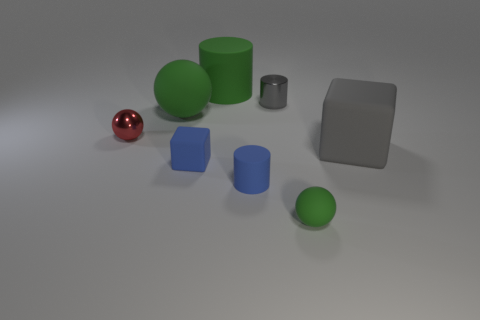There is a block behind the tiny blue rubber object that is on the left side of the small blue rubber thing that is on the right side of the green cylinder; what color is it?
Ensure brevity in your answer.  Gray. Is the shape of the large gray rubber object the same as the tiny green object?
Your response must be concise. No. Is the number of small gray shiny things in front of the small gray cylinder the same as the number of large green cylinders?
Keep it short and to the point. No. What number of other things are there of the same material as the red thing
Your response must be concise. 1. There is a green thing that is behind the big green rubber ball; does it have the same size as the green object in front of the gray matte cube?
Offer a very short reply. No. How many things are either tiny metallic things that are in front of the tiny gray metallic cylinder or big blocks behind the tiny blue cube?
Offer a very short reply. 2. Is there anything else that has the same shape as the red object?
Provide a succinct answer. Yes. Is the color of the tiny sphere that is on the left side of the tiny shiny cylinder the same as the matte cube right of the gray cylinder?
Your response must be concise. No. How many matte things are tiny cyan cylinders or cubes?
Your response must be concise. 2. Are there any other things that have the same size as the green cylinder?
Offer a very short reply. Yes. 